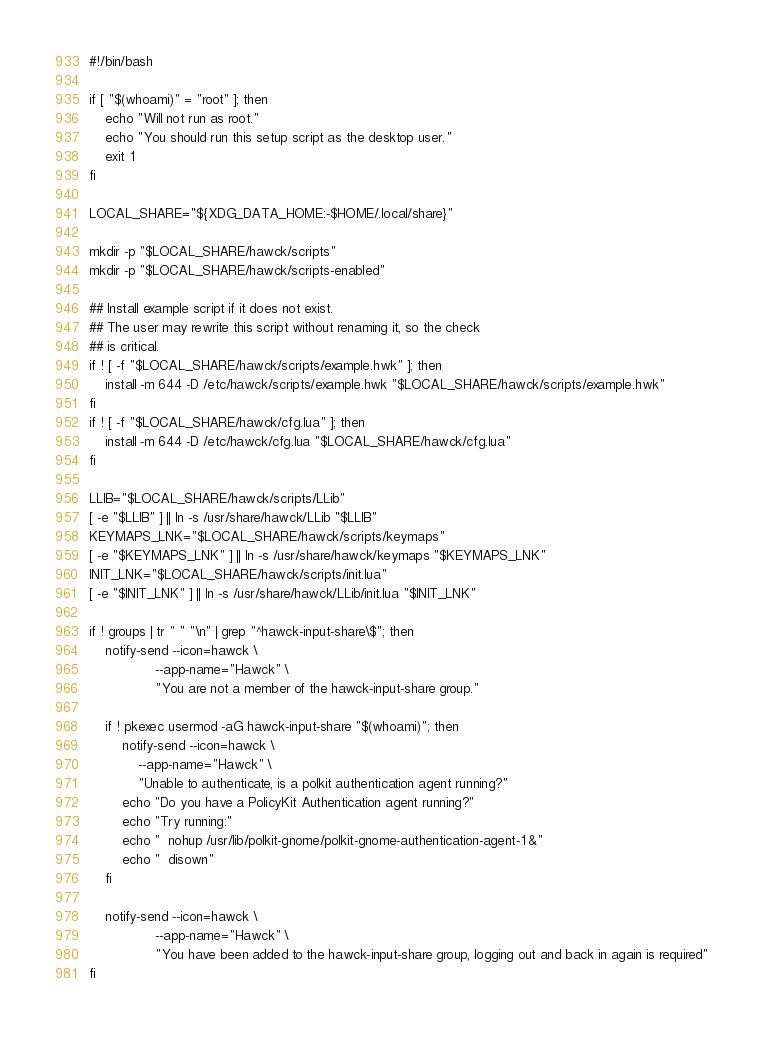<code> <loc_0><loc_0><loc_500><loc_500><_Bash_>#!/bin/bash

if [ "$(whoami)" = "root" ]; then
    echo "Will not run as root."
    echo "You should run this setup script as the desktop user."
    exit 1
fi

LOCAL_SHARE="${XDG_DATA_HOME:-$HOME/.local/share}"

mkdir -p "$LOCAL_SHARE/hawck/scripts"
mkdir -p "$LOCAL_SHARE/hawck/scripts-enabled"

## Install example script if it does not exist.
## The user may rewrite this script without renaming it, so the check
## is critical.
if ! [ -f "$LOCAL_SHARE/hawck/scripts/example.hwk" ]; then
    install -m 644 -D /etc/hawck/scripts/example.hwk "$LOCAL_SHARE/hawck/scripts/example.hwk"
fi
if ! [ -f "$LOCAL_SHARE/hawck/cfg.lua" ]; then
    install -m 644 -D /etc/hawck/cfg.lua "$LOCAL_SHARE/hawck/cfg.lua"
fi

LLIB="$LOCAL_SHARE/hawck/scripts/LLib"
[ -e "$LLIB" ] || ln -s /usr/share/hawck/LLib "$LLIB"
KEYMAPS_LNK="$LOCAL_SHARE/hawck/scripts/keymaps"
[ -e "$KEYMAPS_LNK" ] || ln -s /usr/share/hawck/keymaps "$KEYMAPS_LNK"
INIT_LNK="$LOCAL_SHARE/hawck/scripts/init.lua"
[ -e "$INIT_LNK" ] || ln -s /usr/share/hawck/LLib/init.lua "$INIT_LNK"

if ! groups | tr " " "\n" | grep "^hawck-input-share\$"; then
    notify-send --icon=hawck \
                --app-name="Hawck" \
                "You are not a member of the hawck-input-share group."

    if ! pkexec usermod -aG hawck-input-share "$(whoami)"; then
        notify-send --icon=hawck \
            --app-name="Hawck" \
            "Unable to authenticate, is a polkit authentication agent running?"
        echo "Do you have a PolicyKit Authentication agent running?"
        echo "Try running:"
        echo "  nohup /usr/lib/polkit-gnome/polkit-gnome-authentication-agent-1 &"
        echo "  disown"
    fi

    notify-send --icon=hawck \
                --app-name="Hawck" \
                "You have been added to the hawck-input-share group, logging out and back in again is required"
fi
</code> 